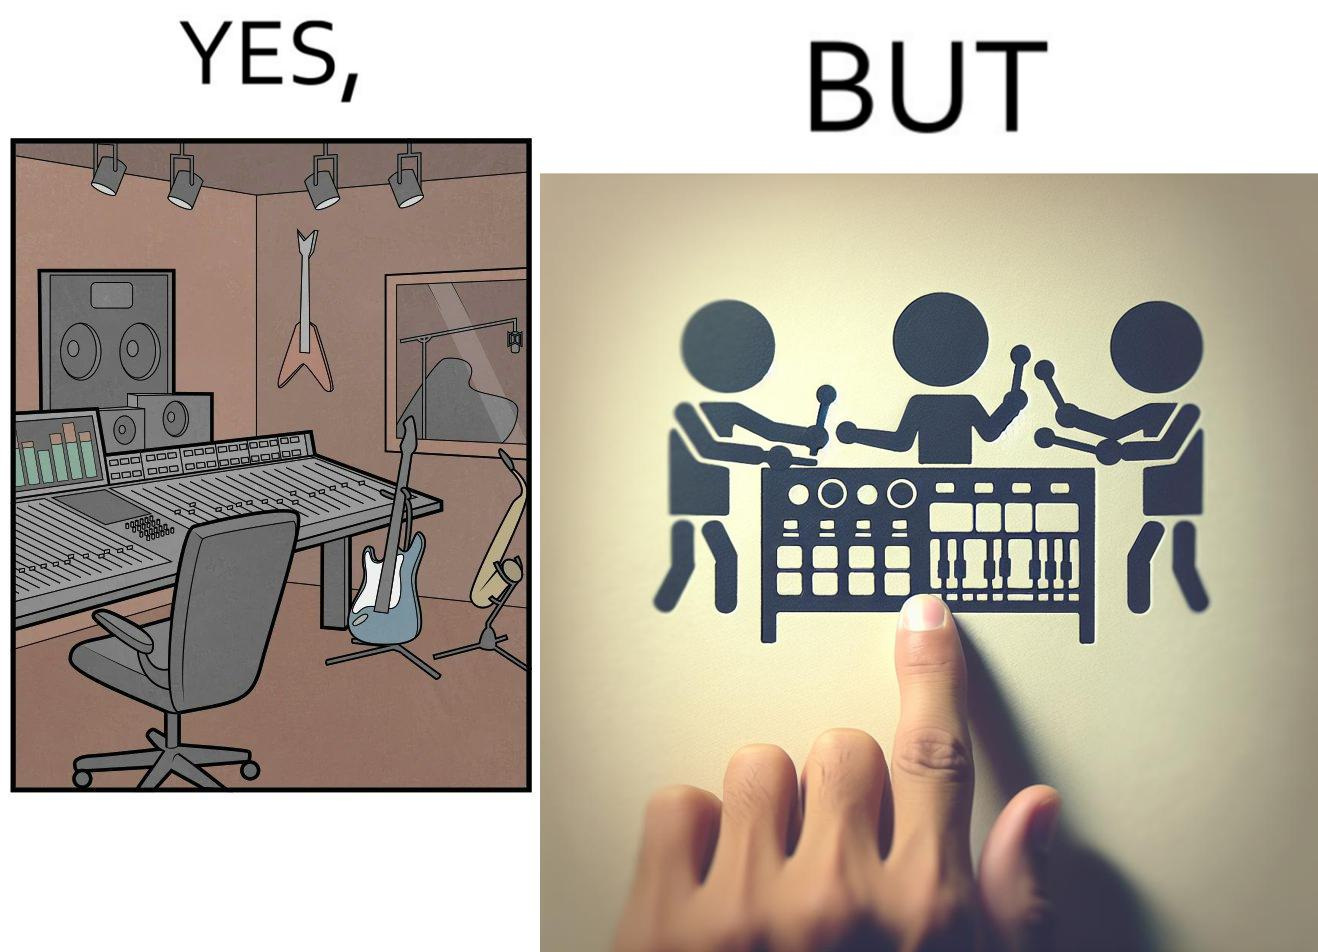What do you see in each half of this image? In the left part of the image: The image shows a music studio with differnt kinds of instruments like guitar and saxophone, piano and recording  to make music. In the right part of the image: The image shows the view of an electornic equipment used to create music. It has buttons to record, play drums and other musical instruments. 